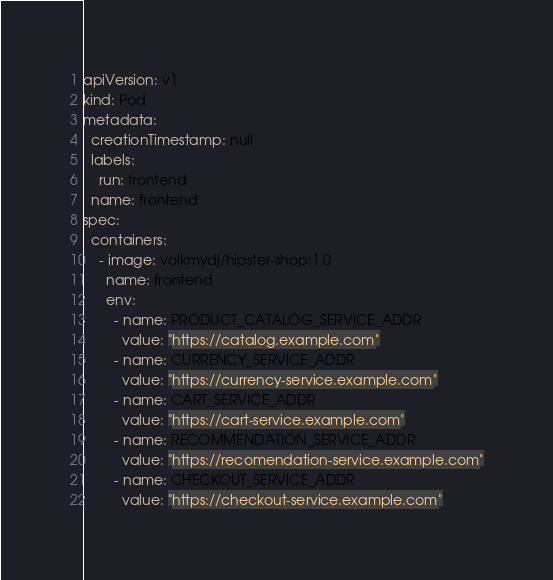<code> <loc_0><loc_0><loc_500><loc_500><_YAML_>apiVersion: v1
kind: Pod
metadata:
  creationTimestamp: null
  labels:
    run: frontend
  name: frontend
spec:
  containers:
    - image: volkmydj/hipster-shop:1.0
      name: frontend
      env:
        - name: PRODUCT_CATALOG_SERVICE_ADDR
          value: "https://catalog.example.com"
        - name: CURRENCY_SERVICE_ADDR
          value: "https://currency-service.example.com"
        - name: CART_SERVICE_ADDR
          value: "https://cart-service.example.com"
        - name: RECOMMENDATION_SERVICE_ADDR
          value: "https://recomendation-service.example.com"
        - name: CHECKOUT_SERVICE_ADDR
          value: "https://checkout-service.example.com"</code> 